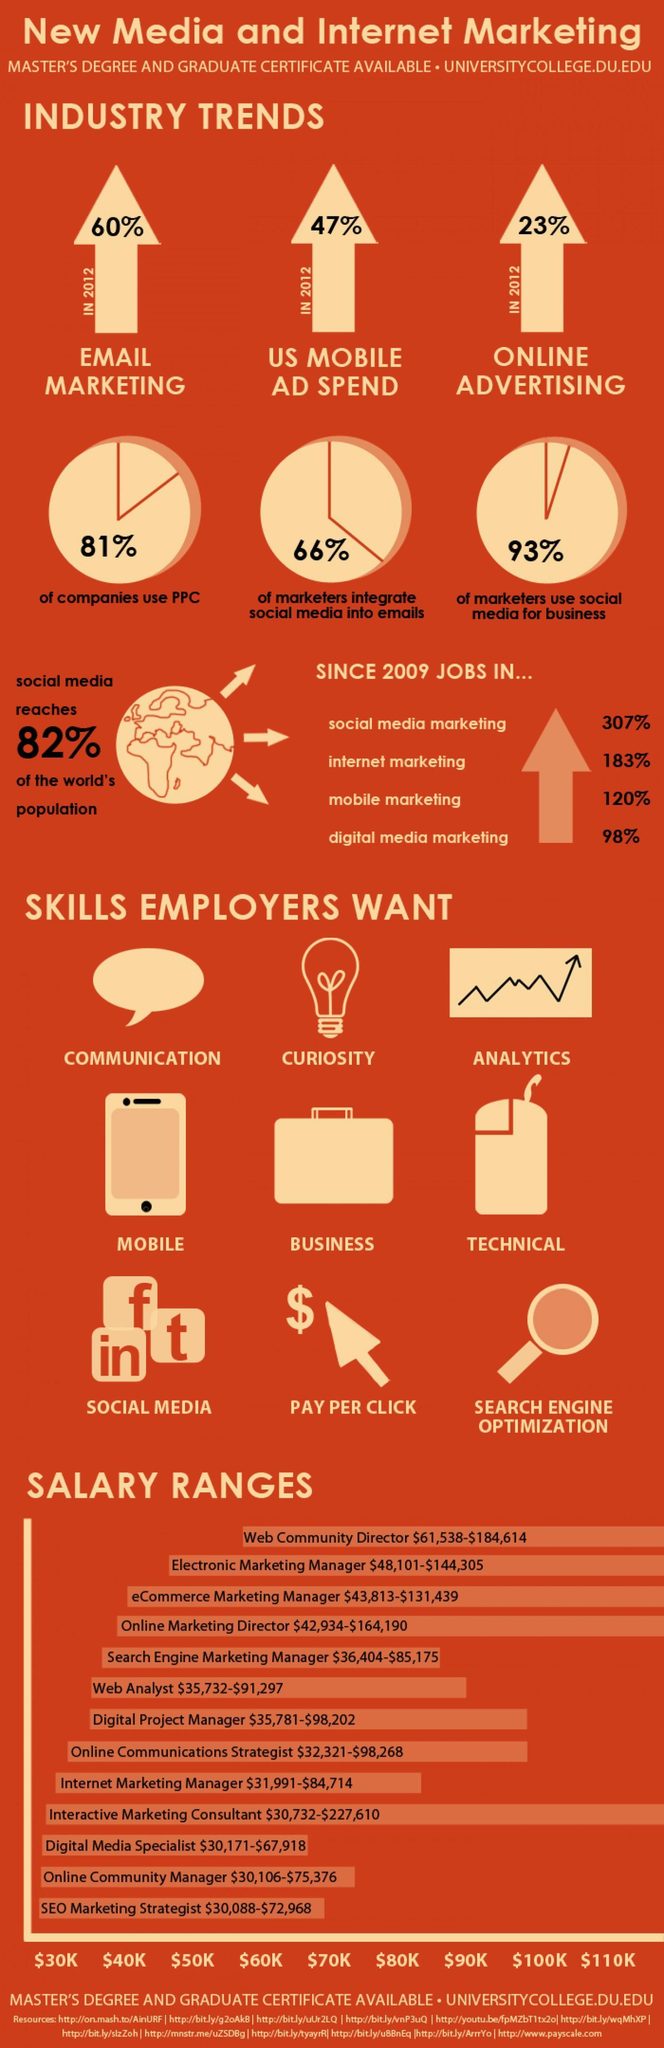What percentage of marketers use social media for business in the U.S.?
Answer the question with a short phrase. 93% Which job profile has the lowest salary range in U.S.? SEO Marketing Strategist What percentage of money US spends on Mobile ADs in 2012? 47% What is the percentage increase of jobs in digital marketing since 2009 in the U.S.? 98% What percentage of money US spends on online advertising in 2012? 23% Which job profile has the highest salary range in U.S.? Web Community Director What is the percentage increase of jobs in internet marketing since 2009 in the U.S.? 183% What is the salary range of a Web Analyst in the U.S.? $35,732-$91,297 